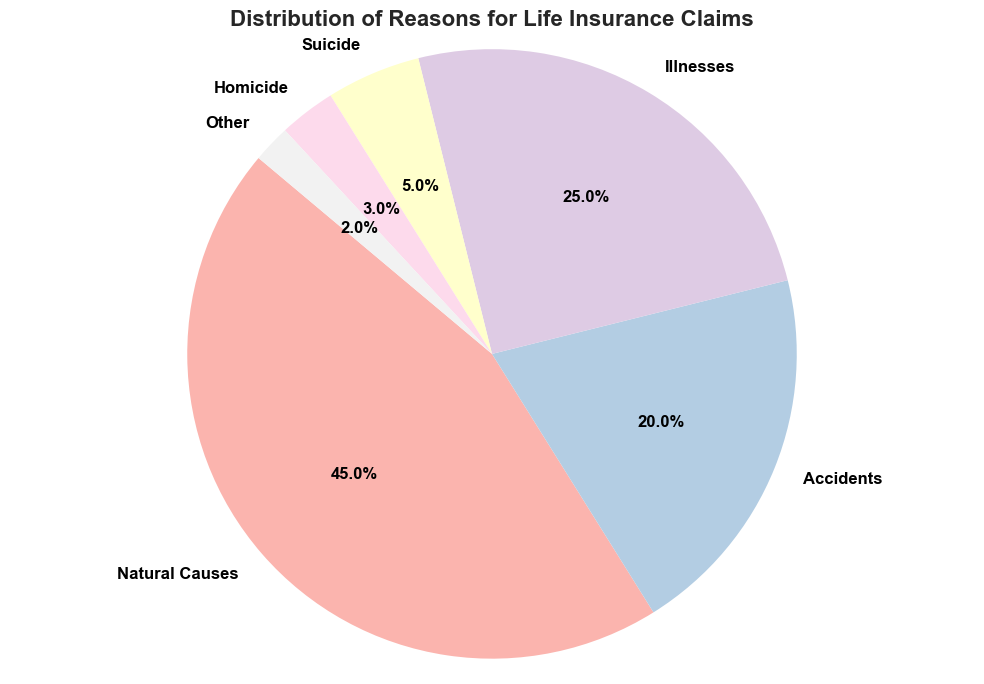Which category has the highest percentage? The pie chart shows that 'Natural Causes' has the largest slice, with a percentage of 45%. So, 'Natural Causes' is the highest category.
Answer: Natural Causes What percentage of claims are due to accidents plus suicides? To find this, add the percentage of 'Accidents' (20%) and 'Suicide' (5%). The sum is 20% + 5% = 25%.
Answer: 25% Which category has a percentage closest to illnesses? The categories are Illnesses (25%), Natural Causes (45%), Accidents (20%), Suicide (5%), Homicide (3%), Other (2%). Accident's percentage (20%) is closest to Illnesses (25%).
Answer: Accidents How many categories have a percentage below 10%? The categories below 10% are 'Suicide' (5%), 'Homicide' (3%), and 'Other' (2%), which makes a total of three categories.
Answer: 3 What is the difference in percentage between natural causes and illnesses? Subtract the percentage of 'Illnesses' (25%) from 'Natural Causes' (45%): 45% - 25% = 20%.
Answer: 20% Are there more claims from accidents or homicides? The percentage of 'Accidents' is 20%, whereas the percentage of 'Homicides' is 3%. 20% is greater than 3%.
Answer: Accidents What is the combined percentage of the least three categories? The least three categories are 'Suicide' (5%), 'Homicide' (3%), and 'Other' (2%). Add these percentages: 5% + 3% + 2% = 10%.
Answer: 10% Which has a larger percentage: 'Suicide' or 'Homicide'? By comparing the percentages, 'Suicide' (5%) is larger than 'Homicide' (3%).
Answer: Suicide 